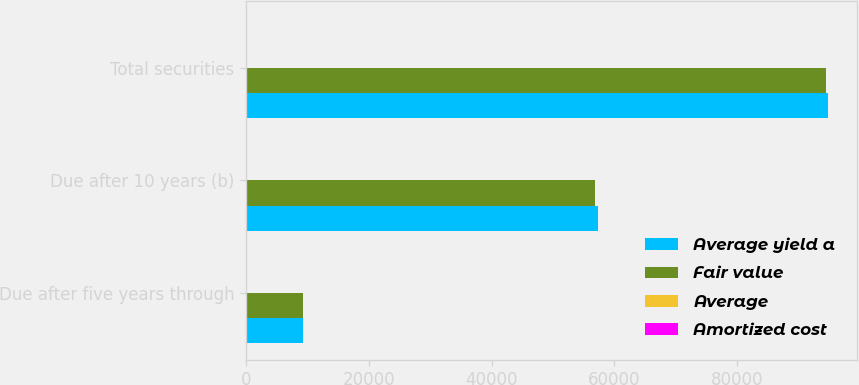Convert chart. <chart><loc_0><loc_0><loc_500><loc_500><stacked_bar_chart><ecel><fcel>Due after five years through<fcel>Due after 10 years (b)<fcel>Total securities<nl><fcel>Average yield a<fcel>9270<fcel>57270<fcel>94821<nl><fcel>Fair value<fcel>9278<fcel>56880<fcel>94402<nl><fcel>Average<fcel>3.77<fcel>4.48<fcel>3.95<nl><fcel>Amortized cost<fcel>16<fcel>101<fcel>117<nl></chart> 